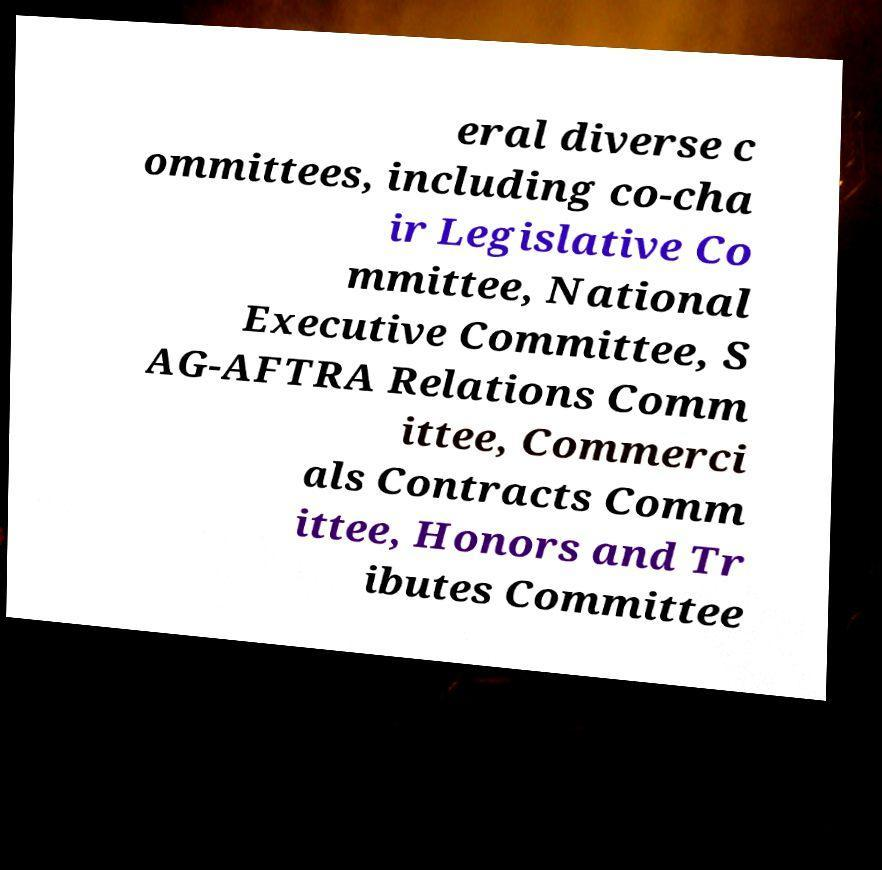What messages or text are displayed in this image? I need them in a readable, typed format. eral diverse c ommittees, including co-cha ir Legislative Co mmittee, National Executive Committee, S AG-AFTRA Relations Comm ittee, Commerci als Contracts Comm ittee, Honors and Tr ibutes Committee 